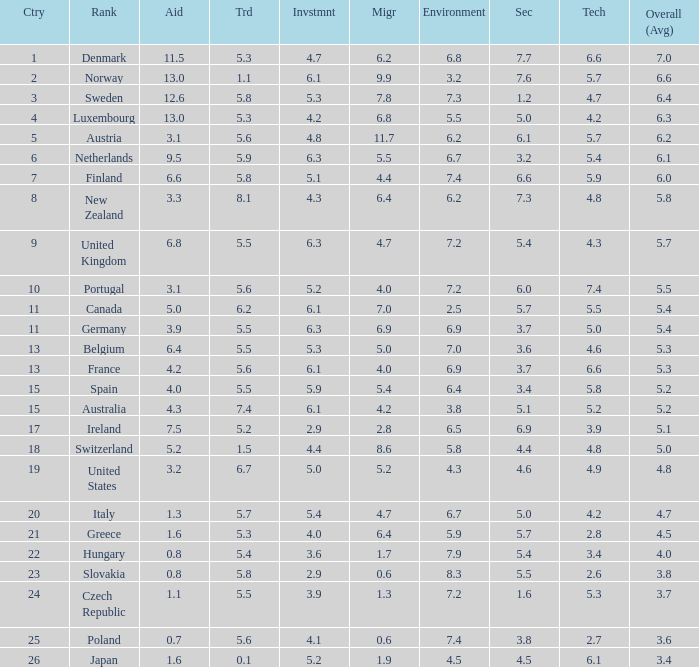How many times is denmark ranked in technology? 1.0. 